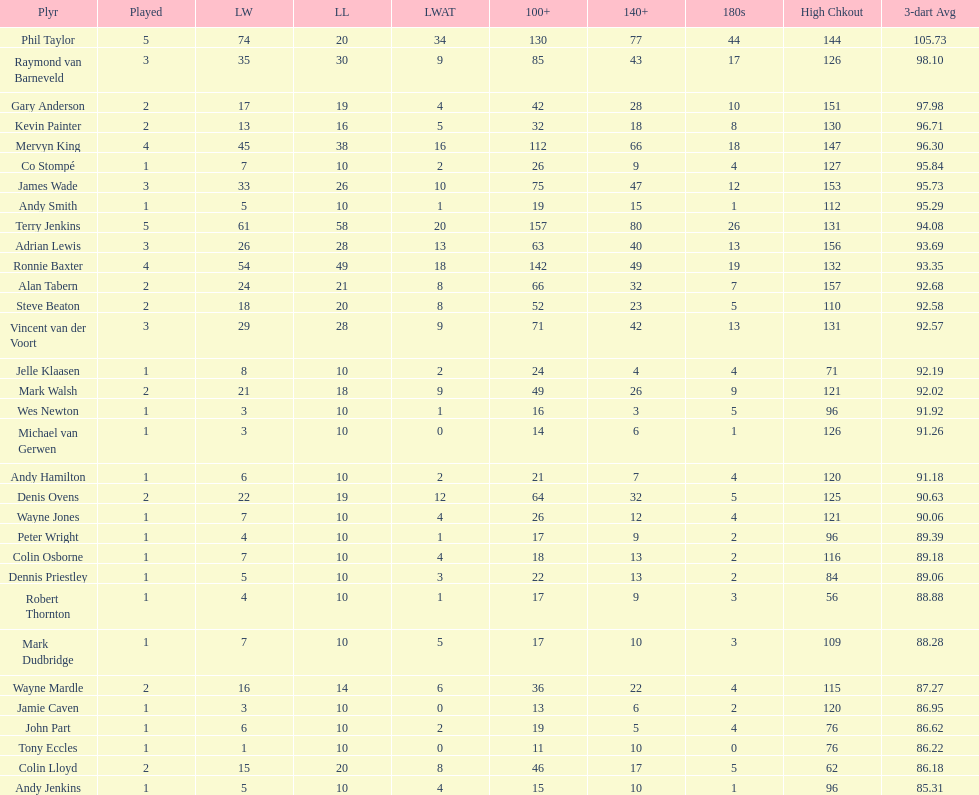What are the number of legs lost by james wade? 26. 